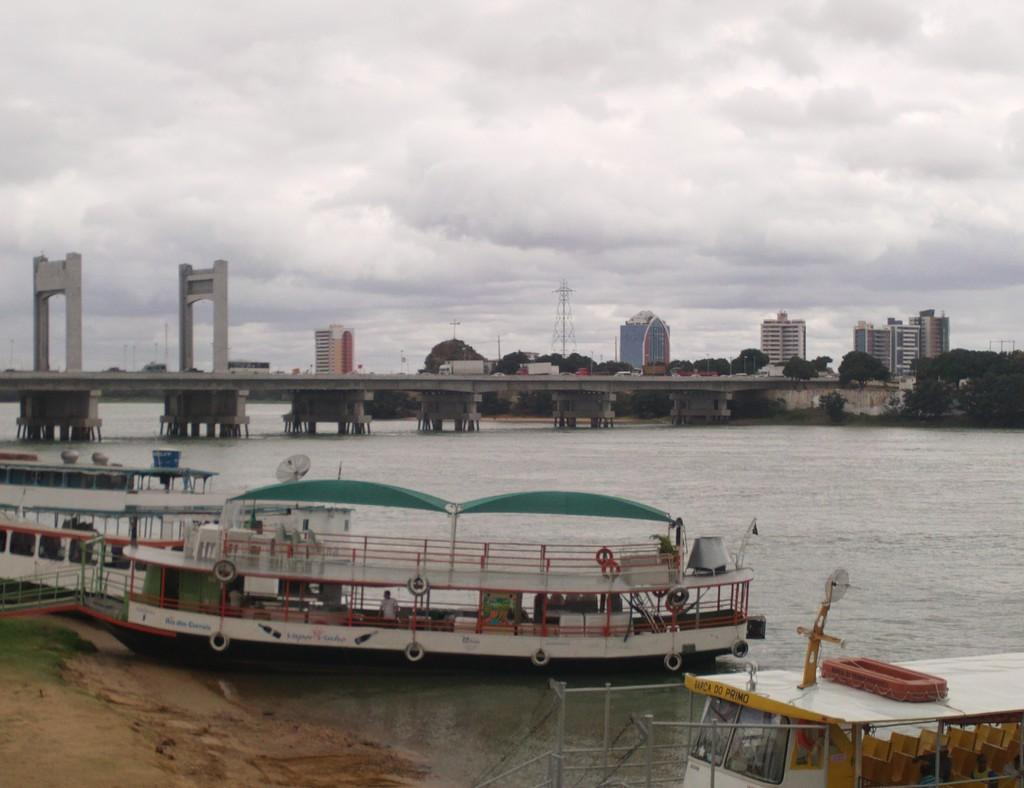What type of vehicles can be seen in the image? There are boats in the image. What is the primary element in which the boats are situated? There is water visible in the image, and the boats are in the water. What type of structure is present in the image? There is a bridge in the image. Can the ground be seen in the image? Yes, the ground is visible in the image. What type of vegetation is present in the image? There is grass in the image. What type of man-made structures can be seen in the image? There are buildings in the image. What is visible in the sky in the image? The sky is visible in the image, and clouds are present in the sky. Can you tell me how many brains are floating in the water in the image? There are no brains present in the image; it features boats in the water. What type of ghost is visible on the bridge in the image? There are no ghosts present in the image; it features a bridge and other elements mentioned in the facts. 